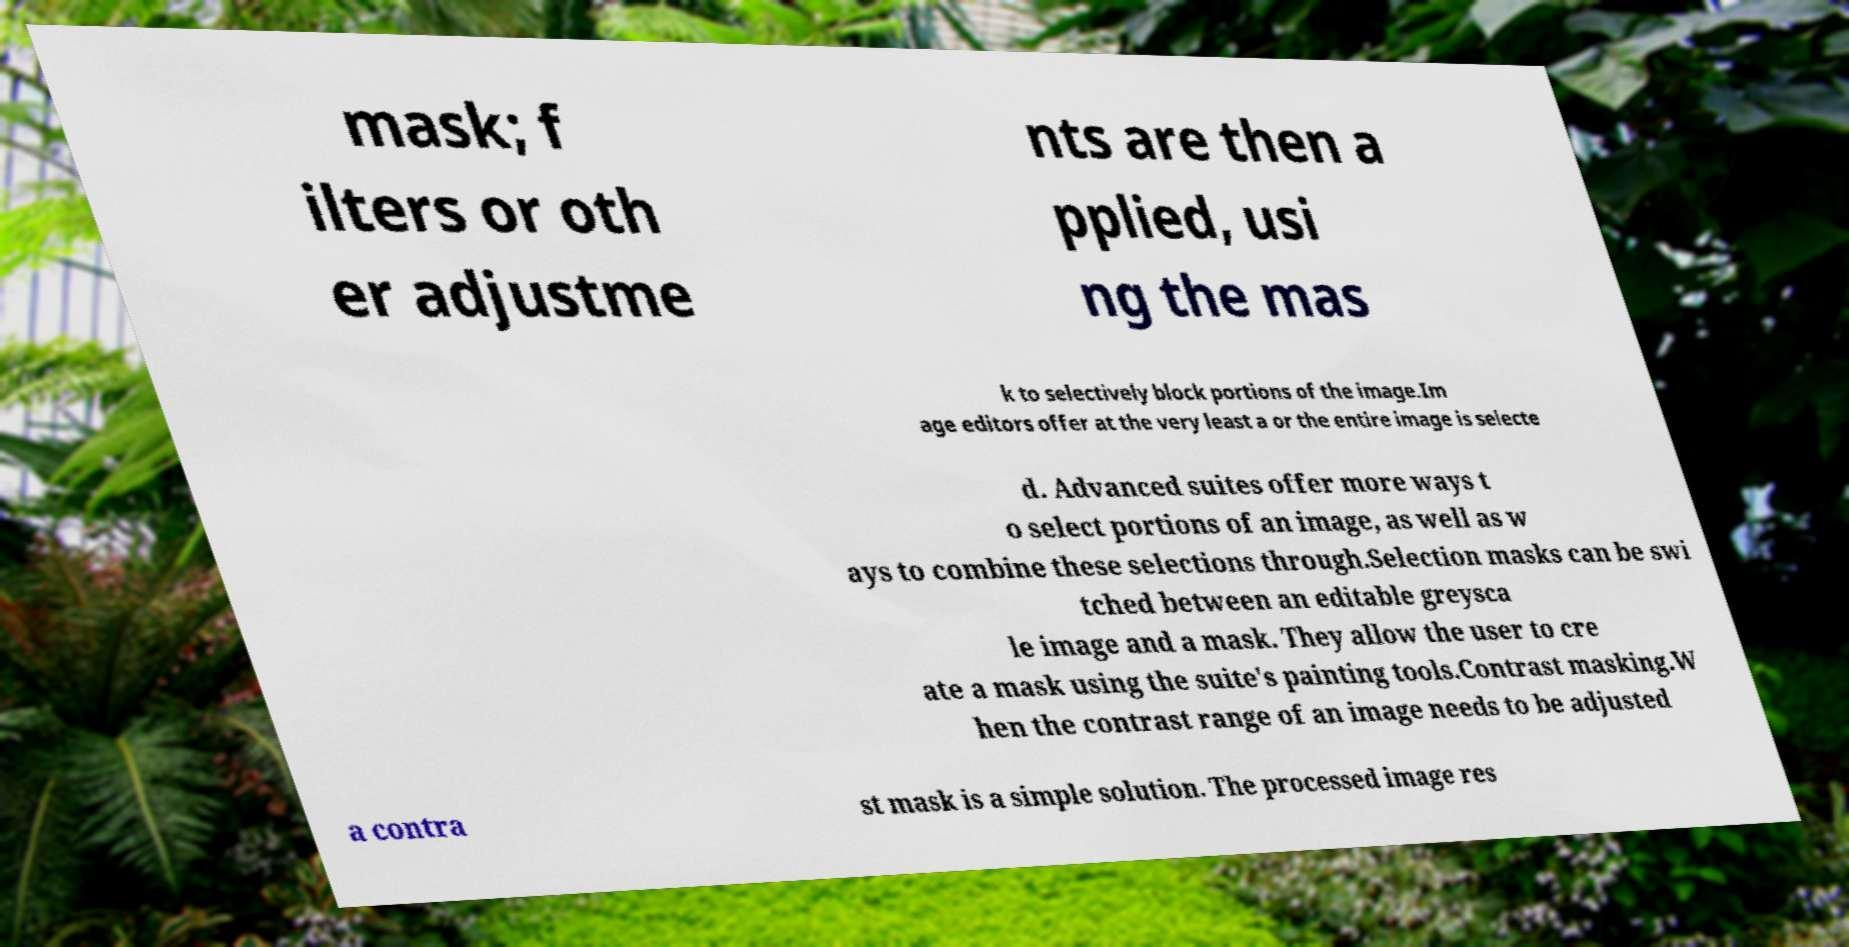What messages or text are displayed in this image? I need them in a readable, typed format. mask; f ilters or oth er adjustme nts are then a pplied, usi ng the mas k to selectively block portions of the image.Im age editors offer at the very least a or the entire image is selecte d. Advanced suites offer more ways t o select portions of an image, as well as w ays to combine these selections through.Selection masks can be swi tched between an editable greysca le image and a mask. They allow the user to cre ate a mask using the suite's painting tools.Contrast masking.W hen the contrast range of an image needs to be adjusted a contra st mask is a simple solution. The processed image res 